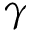Convert formula to latex. <formula><loc_0><loc_0><loc_500><loc_500>\gamma</formula> 